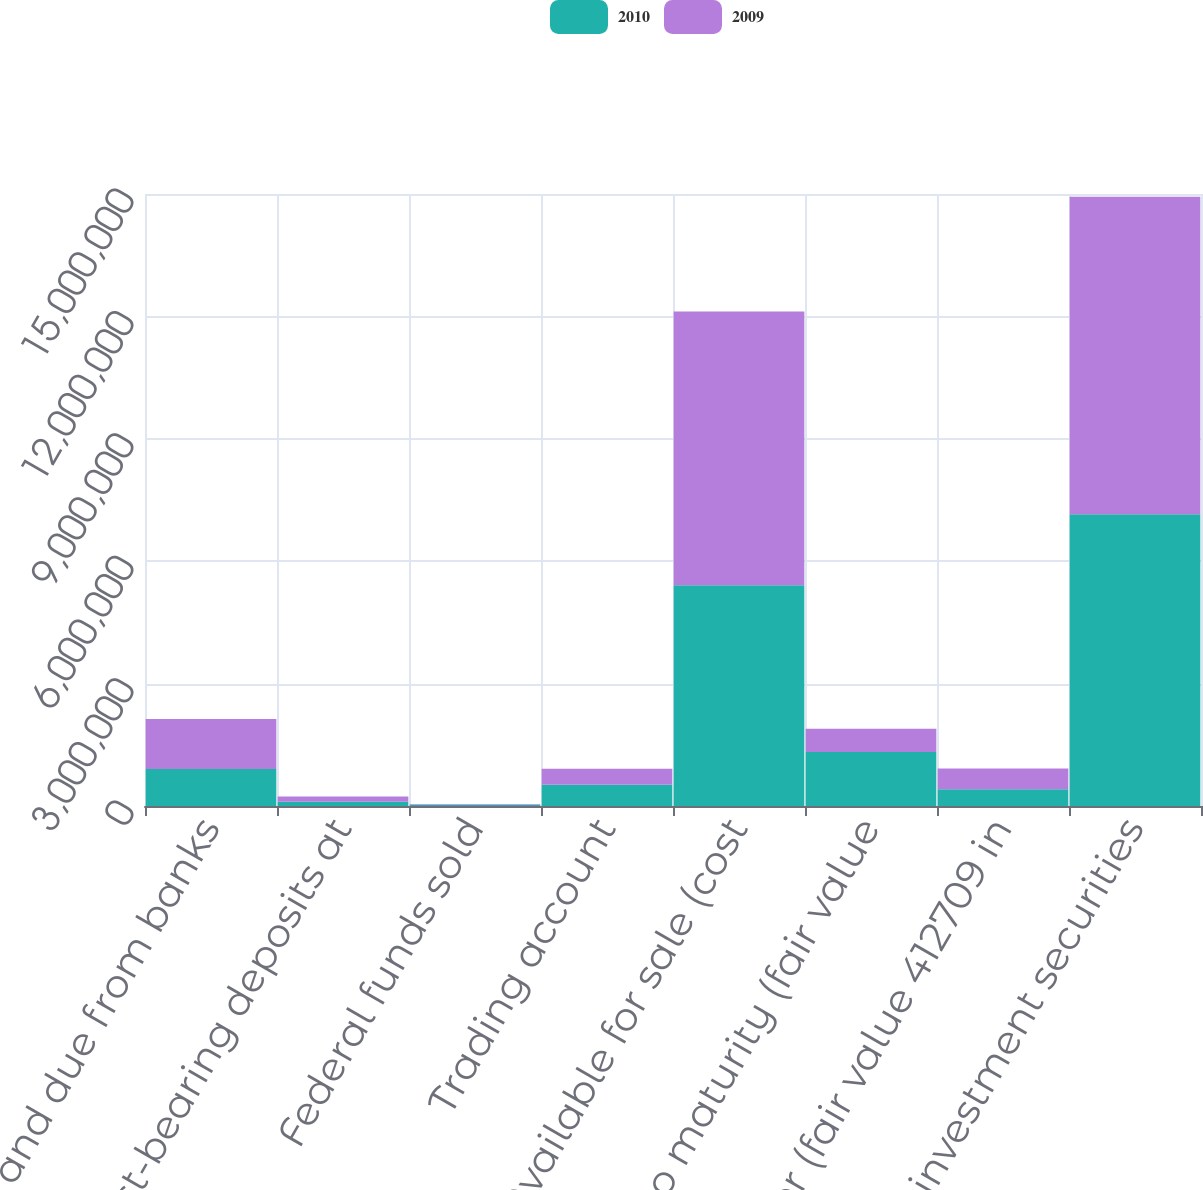<chart> <loc_0><loc_0><loc_500><loc_500><stacked_bar_chart><ecel><fcel>Cash and due from banks<fcel>Interest-bearing deposits at<fcel>Federal funds sold<fcel>Trading account<fcel>Available for sale (cost<fcel>Held to maturity (fair value<fcel>Other (fair value 412709 in<fcel>Total investment securities<nl><fcel>2010<fcel>908755<fcel>101222<fcel>25000<fcel>523834<fcel>5.41349e+06<fcel>1.32434e+06<fcel>412709<fcel>7.15054e+06<nl><fcel>2009<fcel>1.22622e+06<fcel>133335<fcel>20119<fcel>386984<fcel>6.70438e+06<fcel>567607<fcel>508624<fcel>7.78061e+06<nl></chart> 